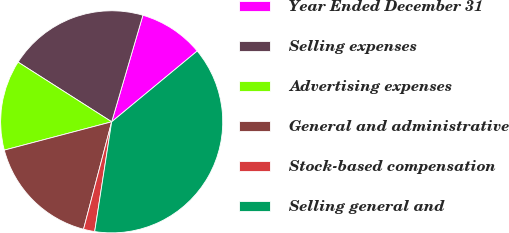Convert chart to OTSL. <chart><loc_0><loc_0><loc_500><loc_500><pie_chart><fcel>Year Ended December 31<fcel>Selling expenses<fcel>Advertising expenses<fcel>General and administrative<fcel>Stock-based compensation<fcel>Selling general and<nl><fcel>9.46%<fcel>20.5%<fcel>13.14%<fcel>16.82%<fcel>1.63%<fcel>38.45%<nl></chart> 